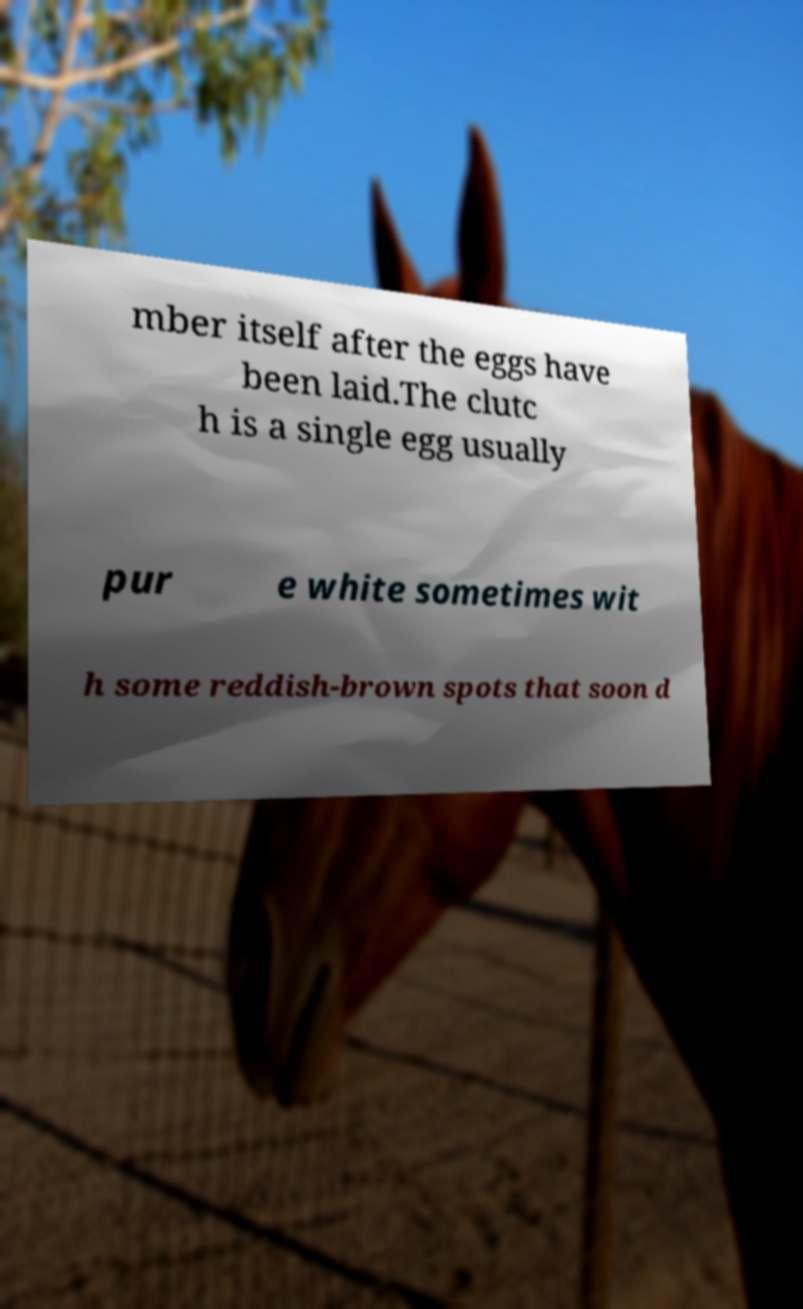Please identify and transcribe the text found in this image. mber itself after the eggs have been laid.The clutc h is a single egg usually pur e white sometimes wit h some reddish-brown spots that soon d 